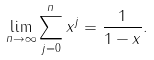Convert formula to latex. <formula><loc_0><loc_0><loc_500><loc_500>\lim _ { n \to \infty } \sum _ { j = 0 } ^ { n } x ^ { j } = \frac { 1 } { 1 - x } .</formula> 